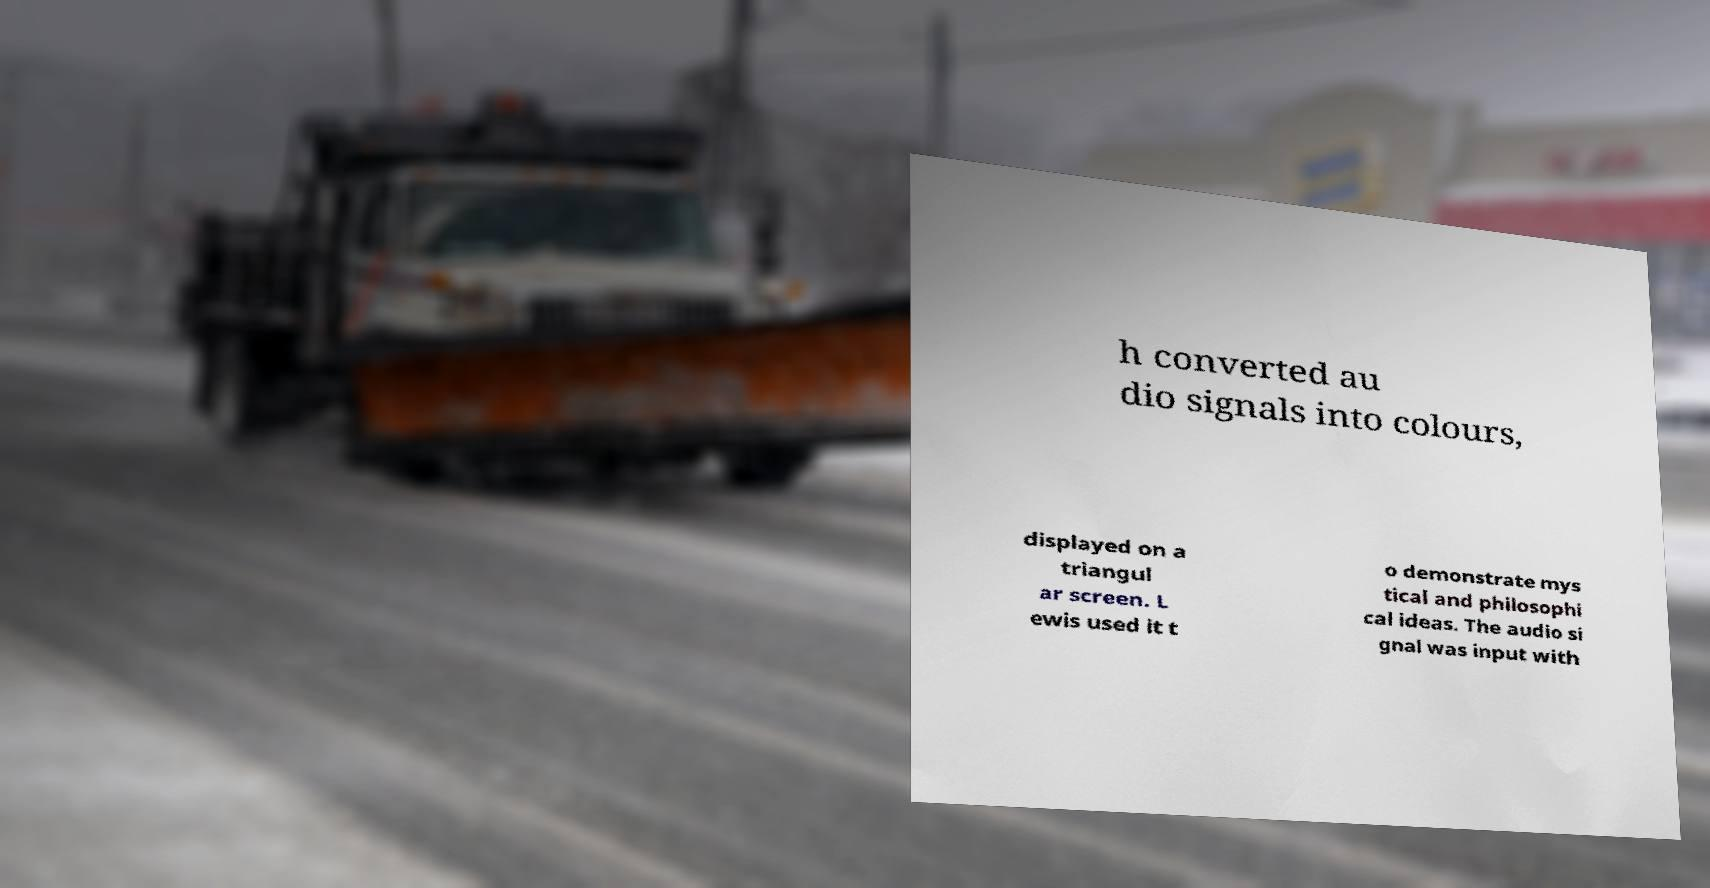For documentation purposes, I need the text within this image transcribed. Could you provide that? h converted au dio signals into colours, displayed on a triangul ar screen. L ewis used it t o demonstrate mys tical and philosophi cal ideas. The audio si gnal was input with 